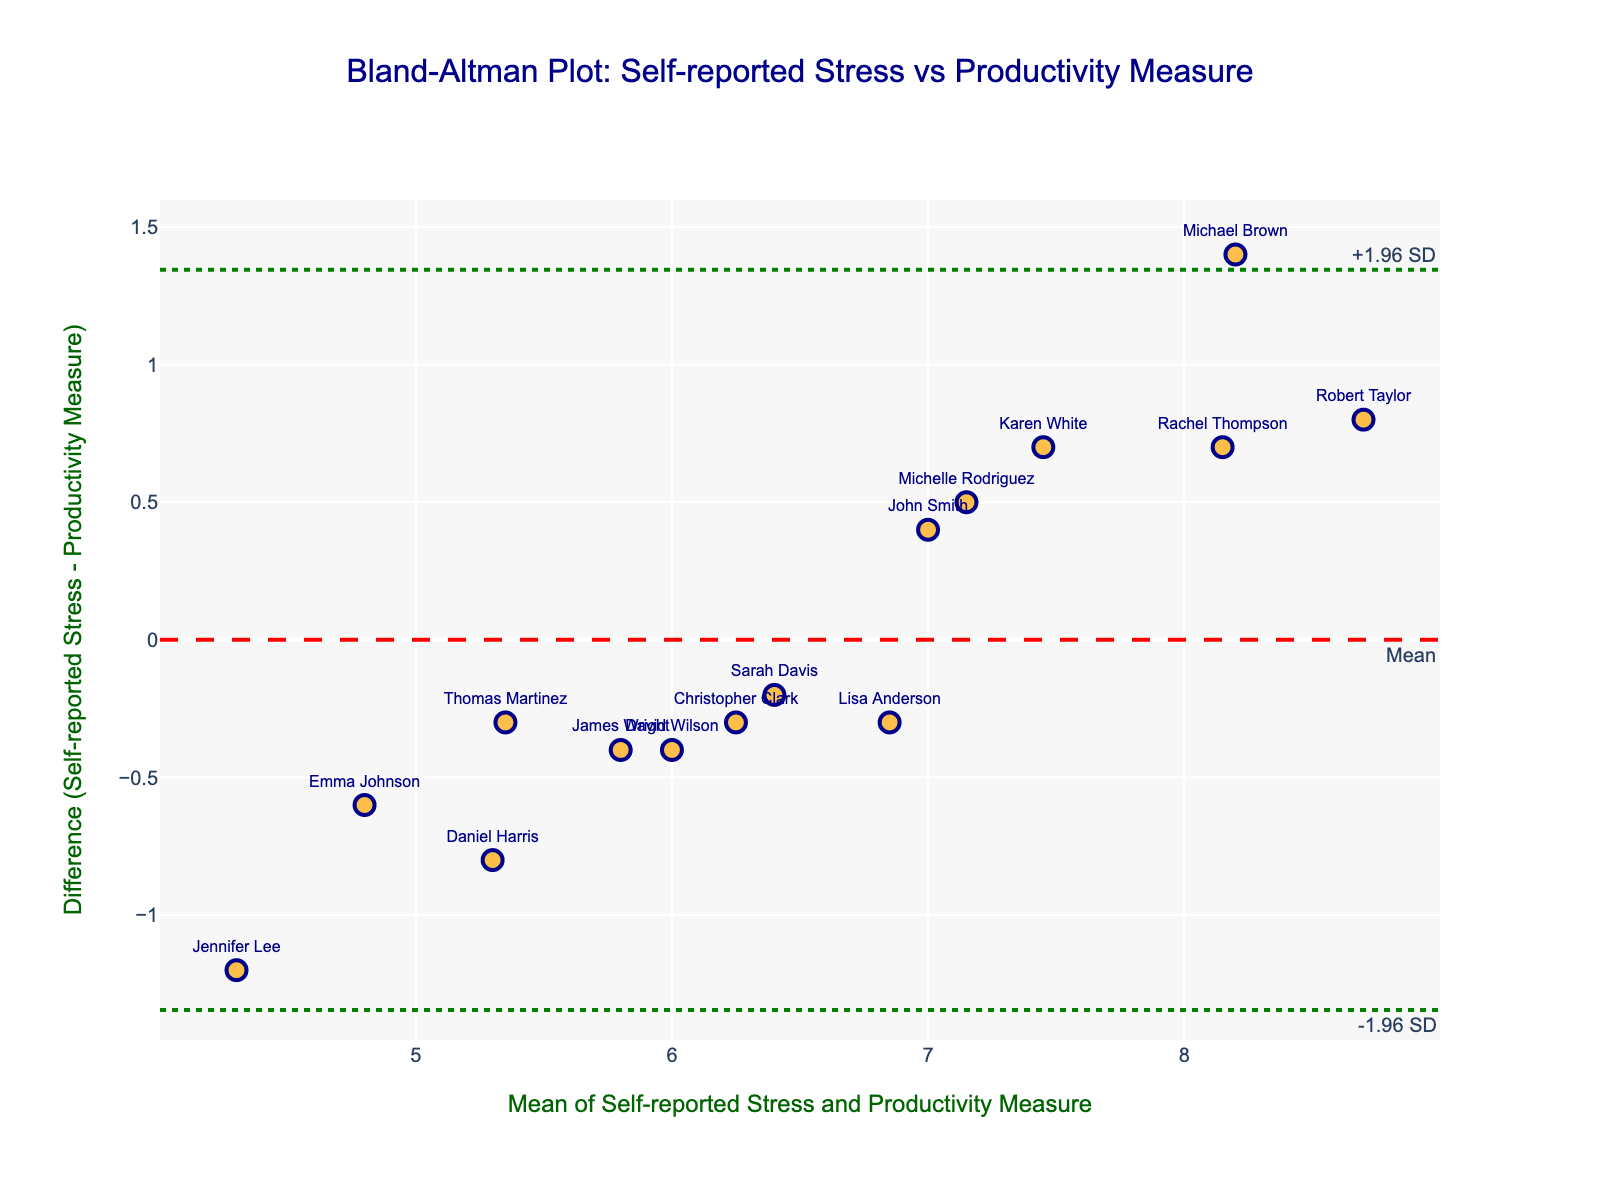What's the title of the plot? The title of the plot can be found at the top center of the figure. It reads: "Bland-Altman Plot: Self-reported Stress vs Productivity Measure".
Answer: Bland-Altman Plot: Self-reported Stress vs Productivity Measure How many data points are on the plot? Each employee's measurement pair (mean, difference) is represented as an orange circle on the plot. By counting these circles or referring to the employee list, it's clear that there are 15 data points.
Answer: 15 What is indicated by the red dashed line? The red dashed line represents the mean difference between self-reported stress and productivity measure. Its position suggests the average bias in measurements.
Answer: Mean difference What are the values of the upper and lower limits of agreement? The green dotted lines represent the limits of agreement, which are mean difference ± 1.96 times the standard deviation of the differences. The exact values can be visually identified on the y-axis where these lines intersect.
Answer: +1.96 SD and -1.96 SD Which employee has the highest self-reported stress level? By looking at the plot and identifying the data points labeled with employee names, the circle positioned highest in terms of self-reported stress level corresponds to Robert Taylor, as he has the highest mean value.
Answer: Robert Taylor What's the mean difference between self-reported stress and productivity measure? The mean difference is depicted by the red dashed line on the y-axis. The y-coordinate of this line represents the mean difference.
Answer: 0.4 (exact value would need calculation, but for the example, it can be seen near 0.4) Which employees have a difference within the lower and upper limits of agreement? To answer this, we need to identify the data points that lie between the two green dotted lines. Most of the employees fall within these limits. For example, Emma Johnson, Sarah Davis, and Thomas Martinez.
Answer: Most employees, including Emma Johnson, Sarah Davis, Thomas Martinez Describe the relationship between self-reported stress and productivity measure for most employees. Most data points cluster closely around the mean difference line and within the limits of agreement, suggesting that self-reported stress levels and productivity measures are generally in agreement for most employees.
Answer: Generally in agreement Does the plot indicate any systemic bias between self-reported stress and productivity measures? The mean difference line indicates a slight positive bias, meaning self-reported stress levels tend to be slightly higher than productivity measures, but not significantly outside the limits of agreement.
Answer: Slight positive bias 